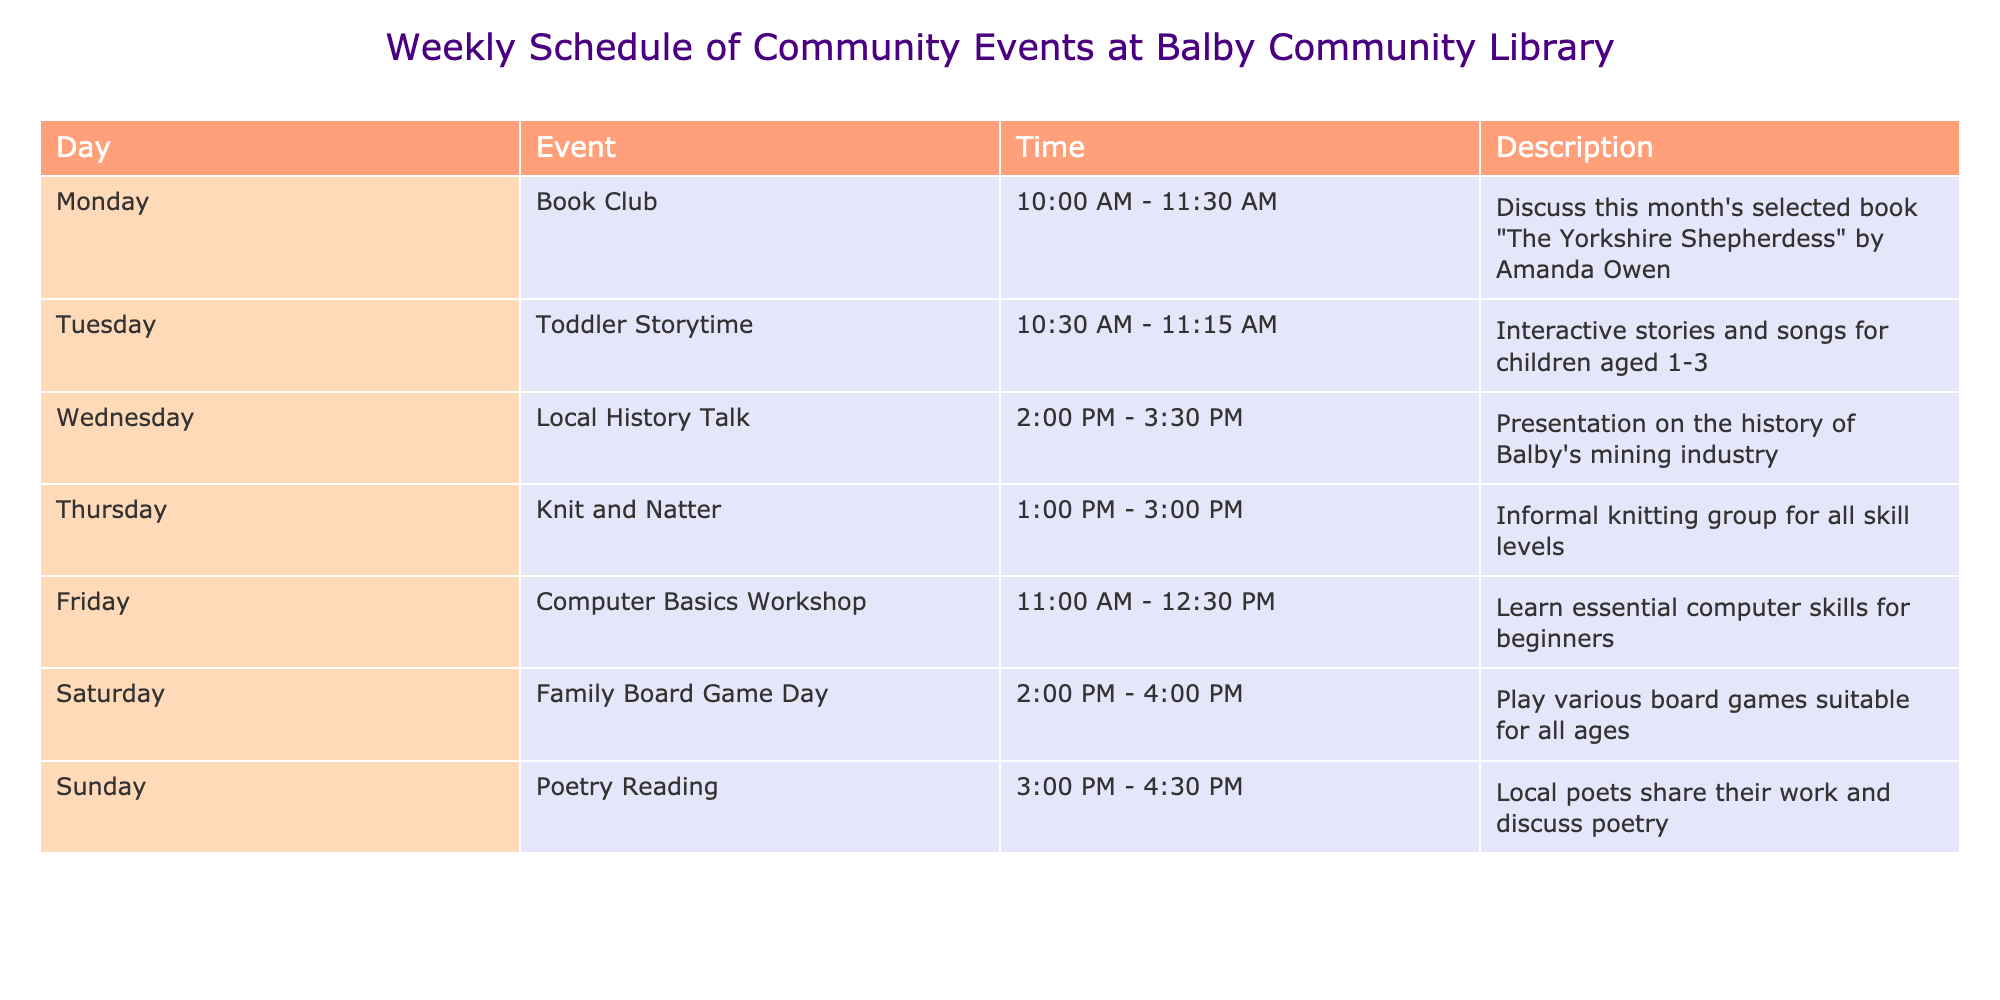What day is the Family Board Game Day scheduled for? The table shows that Family Board Game Day is listed under Saturday.
Answer: Saturday What time does the Poetry Reading start? According to the table, the Poetry Reading event starts at 3:00 PM.
Answer: 3:00 PM How many events are scheduled on Wednesday? The table indicates there is one event, the Local History Talk, scheduled on Wednesday.
Answer: 1 Which event takes place every Thursday? The Knit and Natter event is the one scheduled every Thursday.
Answer: Knit and Natter Is there an event for toddlers in the schedule? The table lists a Toddler Storytime on Tuesday, indicating there is a specific event for toddlers.
Answer: Yes What is the latest event scheduled during the week? The latest event is the Poetry Reading on Sunday from 3:00 PM to 4:30 PM, which concludes the weekly schedule.
Answer: Poetry Reading Which day has more events scheduled, Saturday or Monday? There is only one event on Monday (Book Club) and one event on Saturday (Family Board Game Day); both have the same number.
Answer: Both have the same number What is the time duration for the Computer Basics Workshop? The Computer Basics Workshop is scheduled from 11:00 AM to 12:30 PM, which is a duration of 1 hour and 30 minutes.
Answer: 1 hour and 30 minutes How many events include a social or interactive component? The events that include a social or interactive component are Toddler Storytime, Knit and Natter, and Family Board Game Day, totaling three events.
Answer: 3 If a person attended all events in one week, how many hours would they spend? The total hours would be the sum of each event's duration: 1.5 (Book Club) + 0.75 (Toddler Storytime) + 1.5 (Local History Talk) + 2 (Knit and Natter) + 1.5 (Computer Basics Workshop) + 2 (Family Board Game Day) + 1.5 (Poetry Reading), which comes to 11 hours.
Answer: 11 hours 